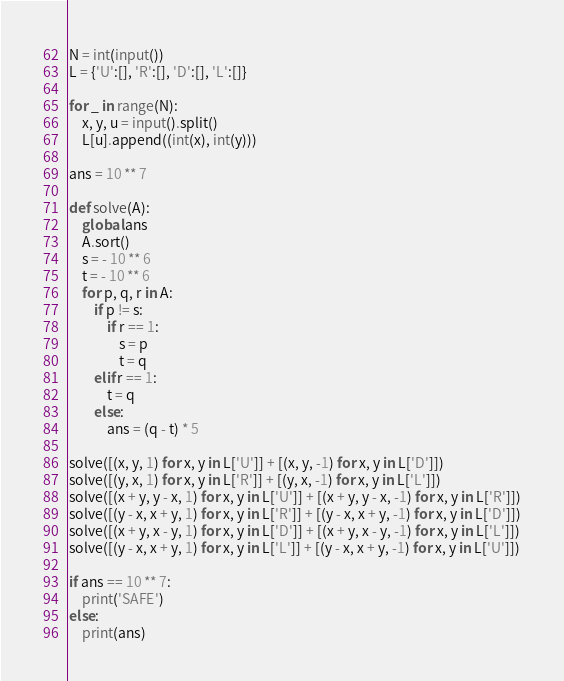<code> <loc_0><loc_0><loc_500><loc_500><_Python_>N = int(input())
L = {'U':[], 'R':[], 'D':[], 'L':[]}

for _ in range(N):
    x, y, u = input().split()
    L[u].append((int(x), int(y)))

ans = 10 ** 7

def solve(A):
    global ans
    A.sort()
    s = - 10 ** 6
    t = - 10 ** 6
    for p, q, r in A:
        if p != s:
            if r == 1:
                s = p
                t = q
        elif r == 1:
            t = q
        else:
            ans = (q - t) * 5

solve([(x, y, 1) for x, y in L['U']] + [(x, y, -1) for x, y in L['D']])
solve([(y, x, 1) for x, y in L['R']] + [(y, x, -1) for x, y in L['L']])
solve([(x + y, y - x, 1) for x, y in L['U']] + [(x + y, y - x, -1) for x, y in L['R']])
solve([(y - x, x + y, 1) for x, y in L['R']] + [(y - x, x + y, -1) for x, y in L['D']])
solve([(x + y, x - y, 1) for x, y in L['D']] + [(x + y, x - y, -1) for x, y in L['L']])
solve([(y - x, x + y, 1) for x, y in L['L']] + [(y - x, x + y, -1) for x, y in L['U']])

if ans == 10 ** 7:
    print('SAFE')
else:
    print(ans)</code> 